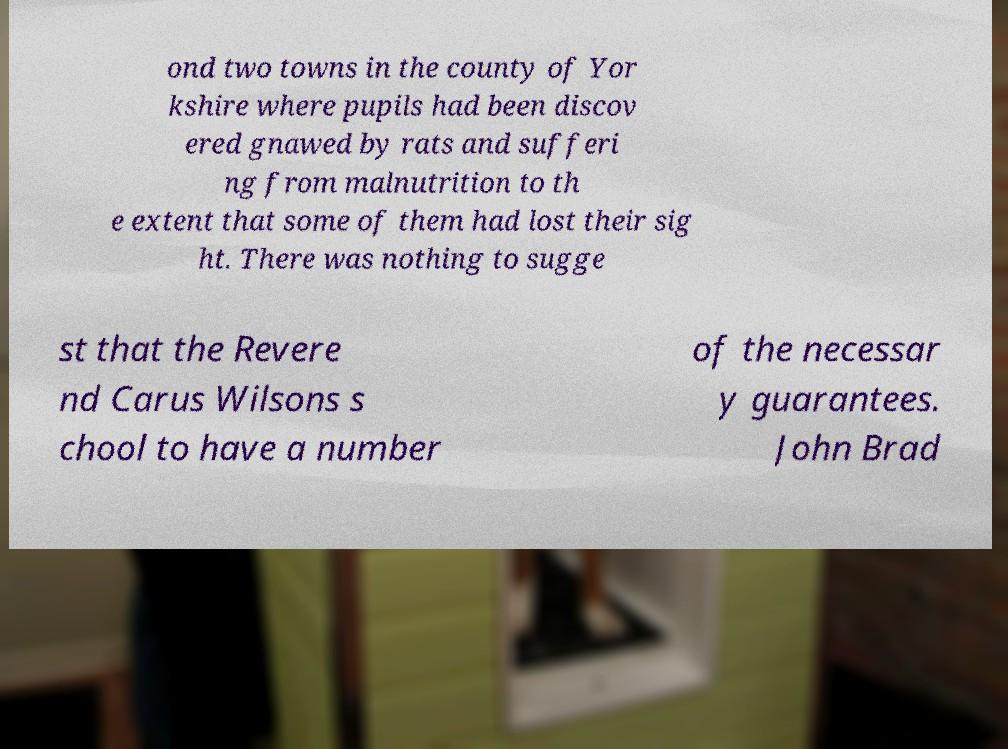Could you extract and type out the text from this image? ond two towns in the county of Yor kshire where pupils had been discov ered gnawed by rats and sufferi ng from malnutrition to th e extent that some of them had lost their sig ht. There was nothing to sugge st that the Revere nd Carus Wilsons s chool to have a number of the necessar y guarantees. John Brad 